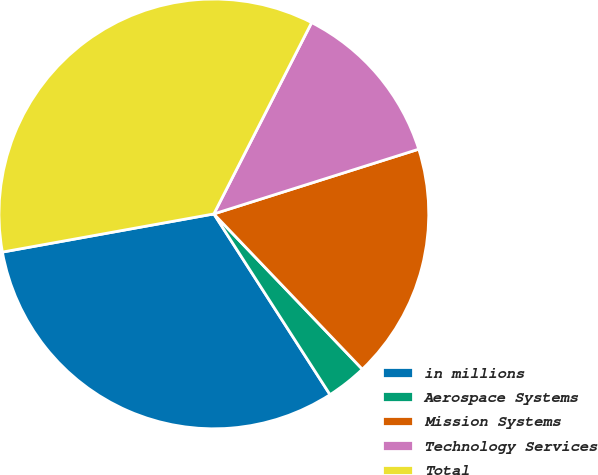Convert chart to OTSL. <chart><loc_0><loc_0><loc_500><loc_500><pie_chart><fcel>in millions<fcel>Aerospace Systems<fcel>Mission Systems<fcel>Technology Services<fcel>Total<nl><fcel>31.25%<fcel>3.05%<fcel>17.73%<fcel>12.61%<fcel>35.36%<nl></chart> 